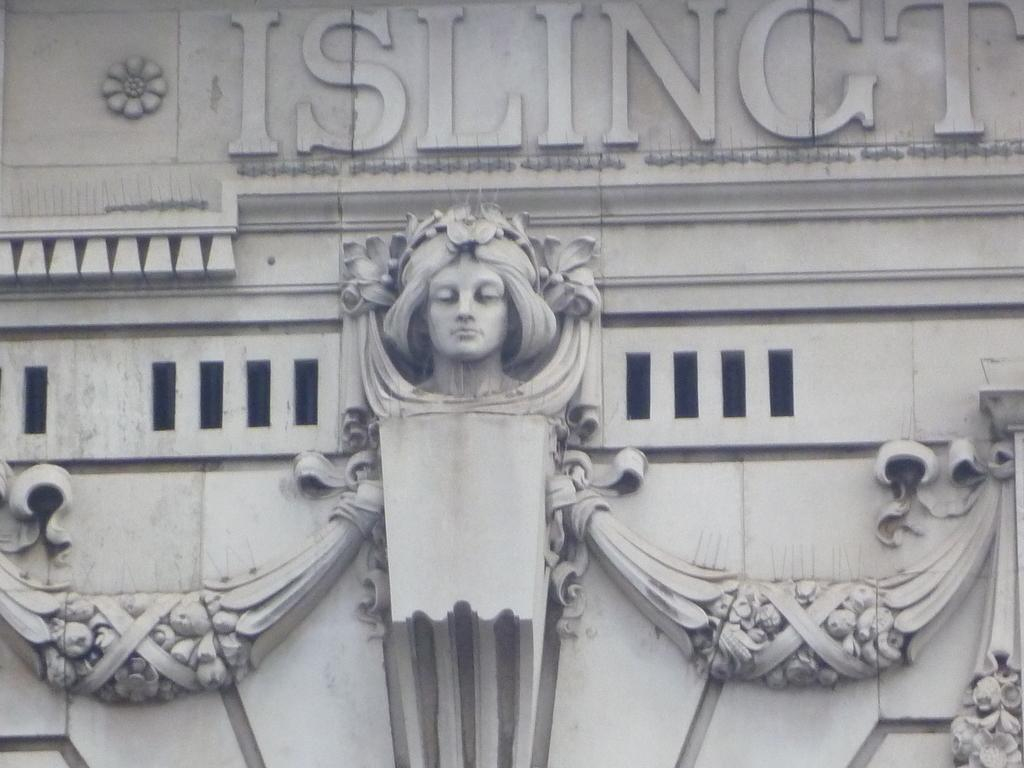What is the main subject of the picture? The main subject of the picture is a sculpture. What else can be seen in the picture besides the sculpture? There are letters on the wall in the picture. What type of music is being played in the background of the picture? There is no information about music being played in the picture, as the facts only mention the sculpture and letters on the wall. 